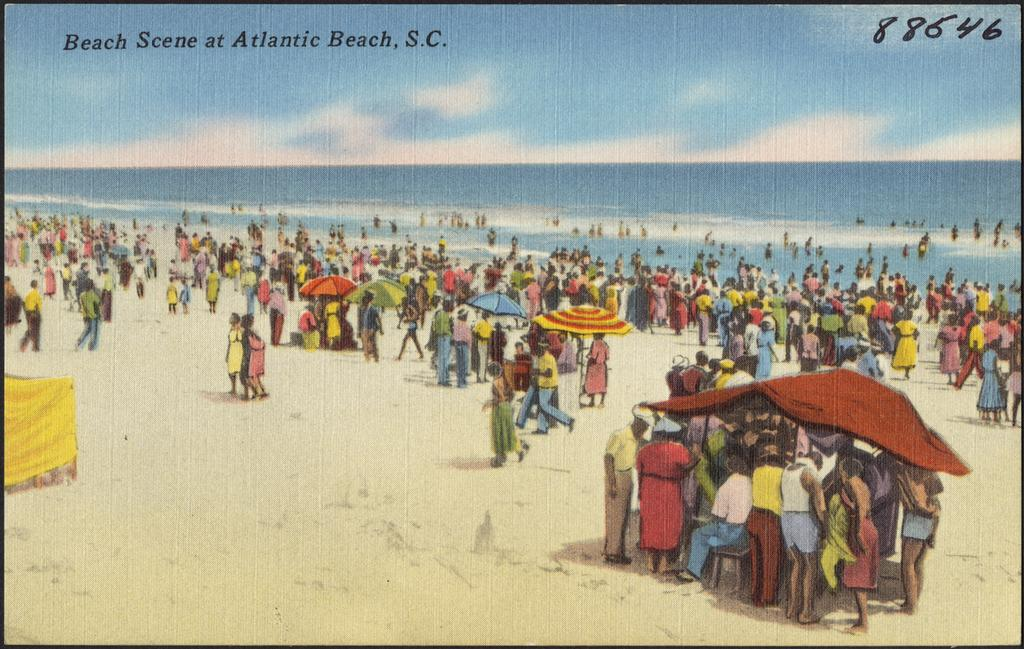<image>
Describe the image concisely. Postcard showing people at a beach and the name Atlantic Beach on the top. 